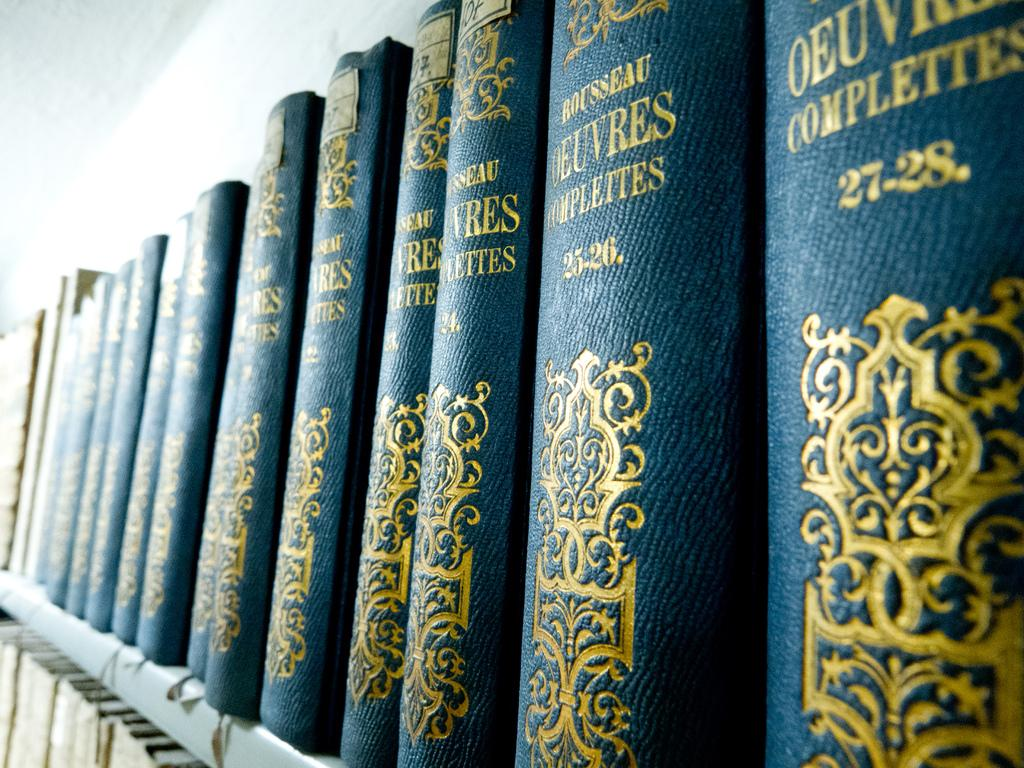<image>
Render a clear and concise summary of the photo. A row of blue books with gold letters that say Rousseau on the binding. 